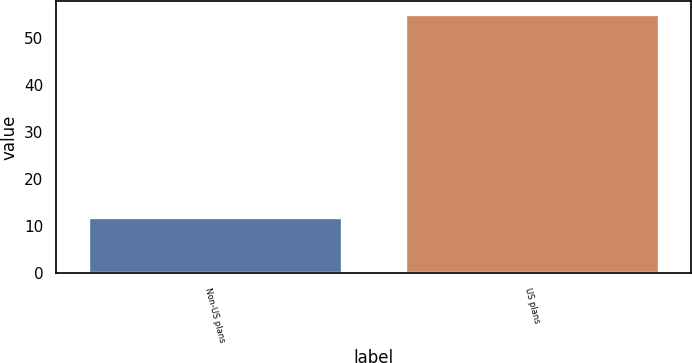Convert chart to OTSL. <chart><loc_0><loc_0><loc_500><loc_500><bar_chart><fcel>Non-US plans<fcel>US plans<nl><fcel>12<fcel>55<nl></chart> 